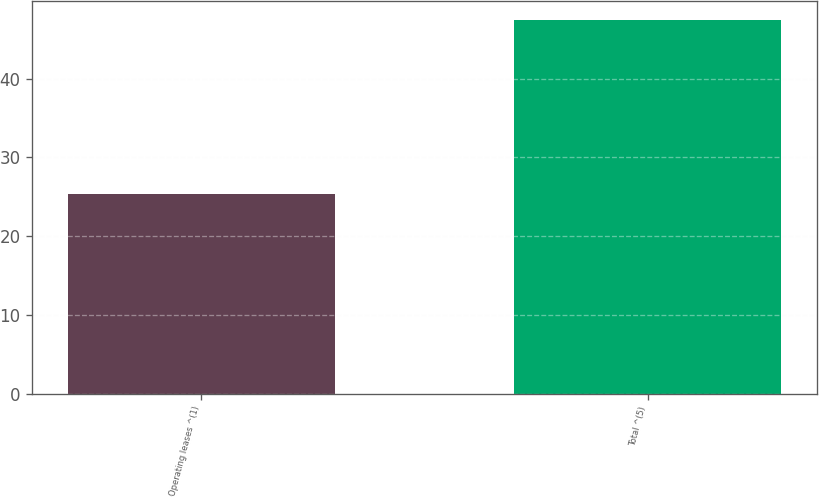Convert chart to OTSL. <chart><loc_0><loc_0><loc_500><loc_500><bar_chart><fcel>Operating leases ^(1)<fcel>Total ^(5)<nl><fcel>25.4<fcel>47.5<nl></chart> 